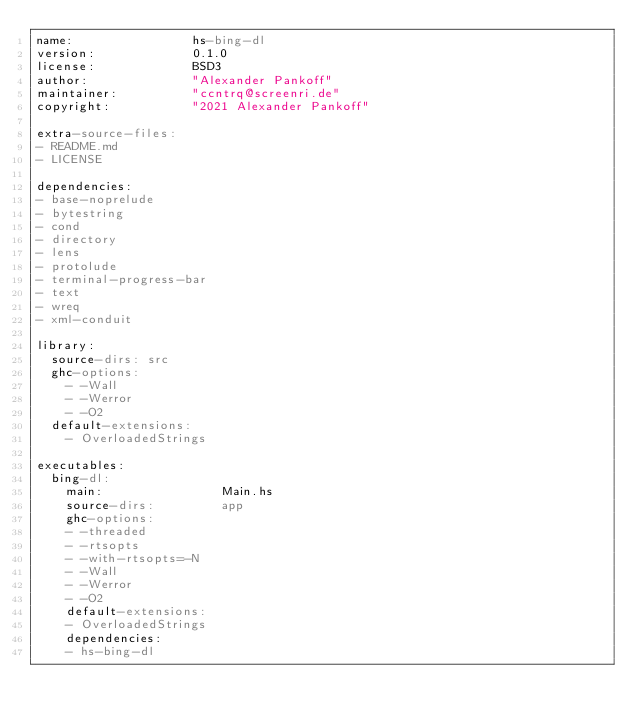Convert code to text. <code><loc_0><loc_0><loc_500><loc_500><_YAML_>name:                hs-bing-dl
version:             0.1.0
license:             BSD3
author:              "Alexander Pankoff"
maintainer:          "ccntrq@screenri.de"
copyright:           "2021 Alexander Pankoff"

extra-source-files:
- README.md
- LICENSE

dependencies:
- base-noprelude
- bytestring
- cond
- directory
- lens
- protolude
- terminal-progress-bar
- text
- wreq
- xml-conduit

library:
  source-dirs: src
  ghc-options:
    - -Wall
    - -Werror
    - -O2
  default-extensions:
    - OverloadedStrings

executables:
  bing-dl:
    main:                Main.hs
    source-dirs:         app
    ghc-options:
    - -threaded
    - -rtsopts
    - -with-rtsopts=-N
    - -Wall
    - -Werror
    - -O2
    default-extensions:
    - OverloadedStrings
    dependencies:
    - hs-bing-dl
</code> 